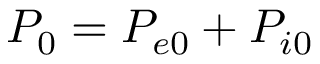Convert formula to latex. <formula><loc_0><loc_0><loc_500><loc_500>P _ { 0 } = P _ { e 0 } + P _ { i 0 }</formula> 